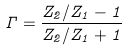<formula> <loc_0><loc_0><loc_500><loc_500>\Gamma = \frac { Z _ { 2 } / Z _ { 1 } - 1 } { Z _ { 2 } / Z _ { 1 } + 1 }</formula> 